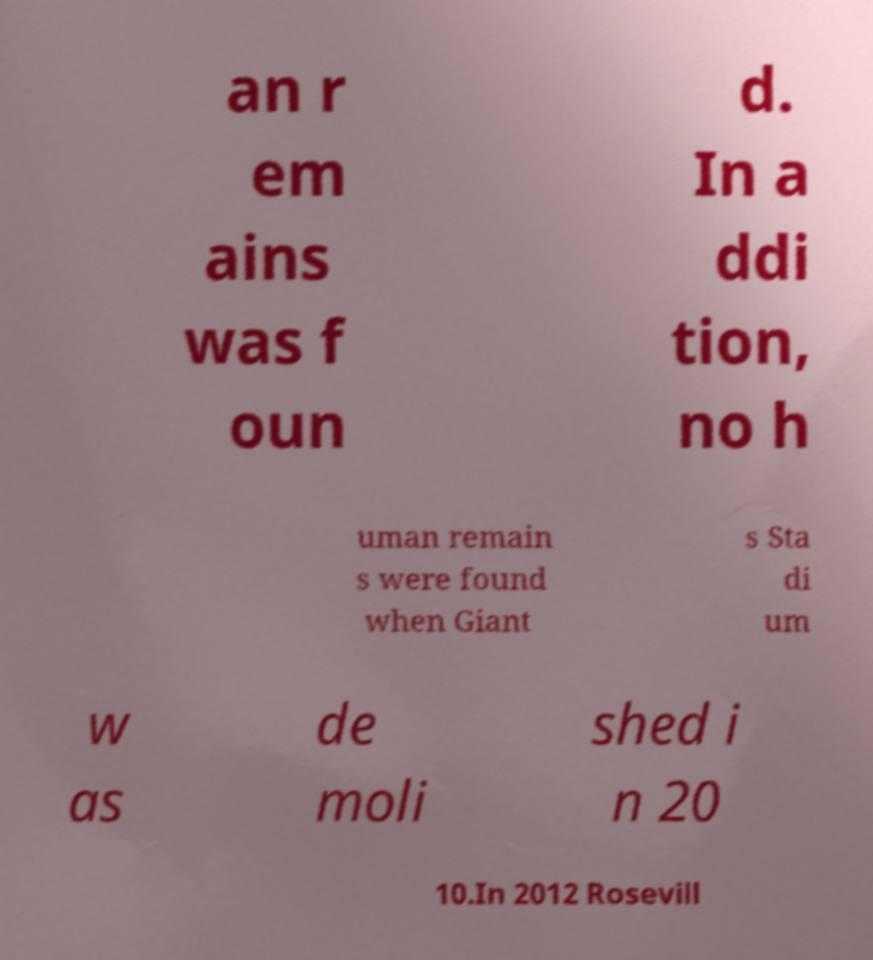Could you extract and type out the text from this image? an r em ains was f oun d. In a ddi tion, no h uman remain s were found when Giant s Sta di um w as de moli shed i n 20 10.In 2012 Rosevill 